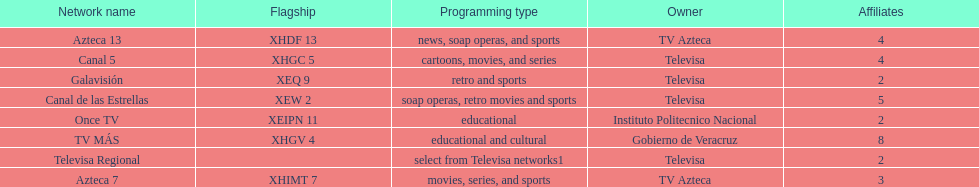Name each of tv azteca's network names. Azteca 7, Azteca 13. 